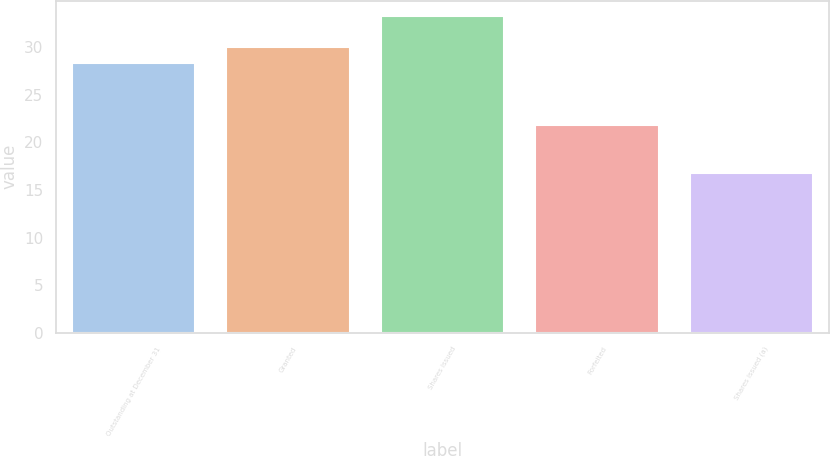Convert chart to OTSL. <chart><loc_0><loc_0><loc_500><loc_500><bar_chart><fcel>Outstanding at December 31<fcel>Granted<fcel>Shares issued<fcel>Forfeited<fcel>Shares issued (a)<nl><fcel>28.39<fcel>30.03<fcel>33.25<fcel>21.83<fcel>16.83<nl></chart> 